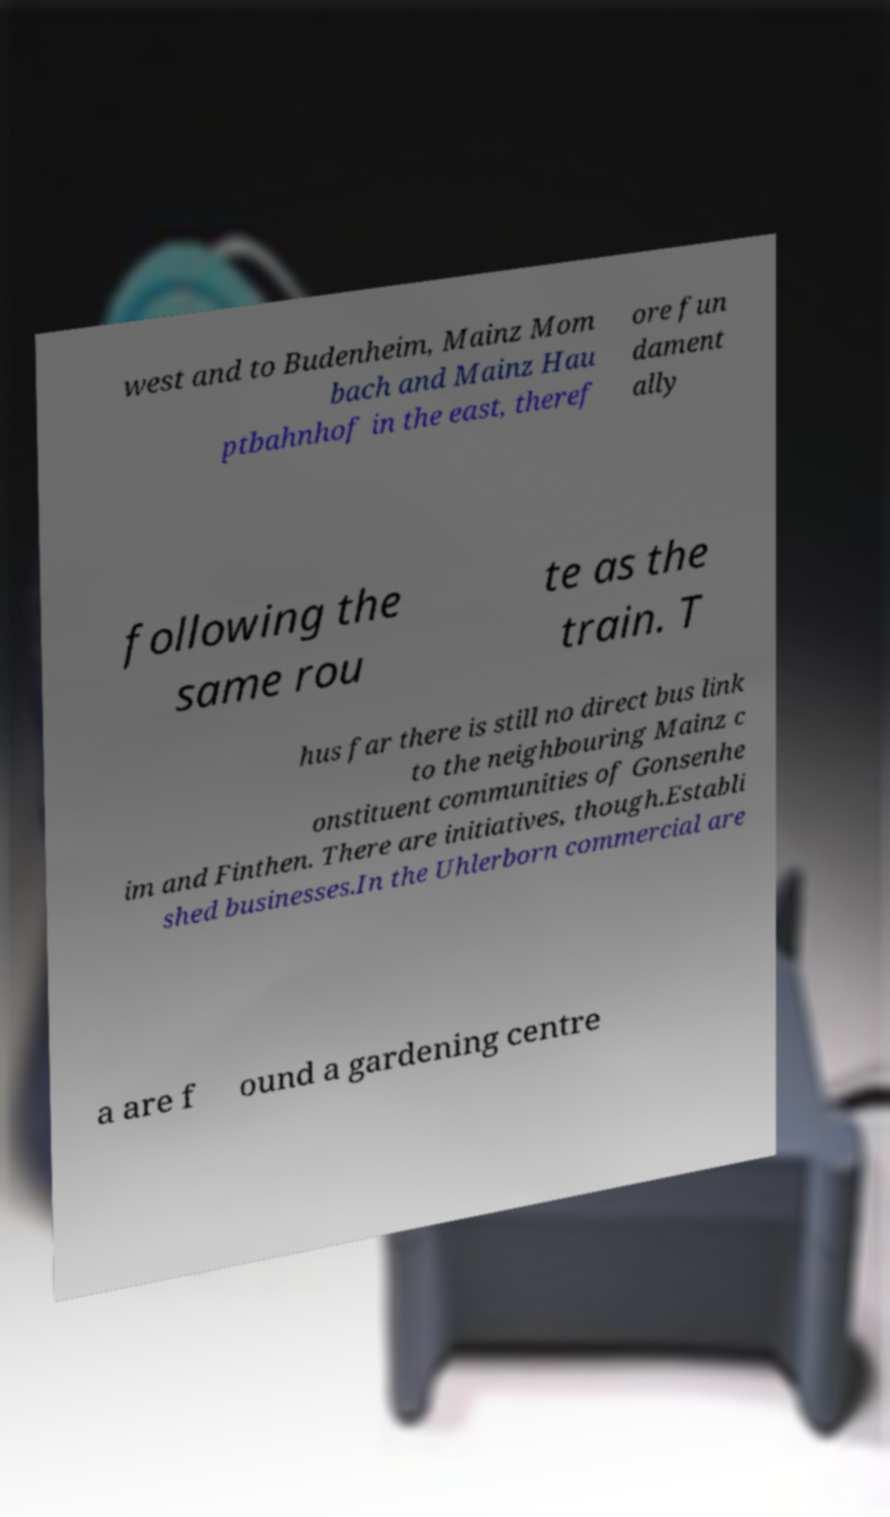Please read and relay the text visible in this image. What does it say? west and to Budenheim, Mainz Mom bach and Mainz Hau ptbahnhof in the east, theref ore fun dament ally following the same rou te as the train. T hus far there is still no direct bus link to the neighbouring Mainz c onstituent communities of Gonsenhe im and Finthen. There are initiatives, though.Establi shed businesses.In the Uhlerborn commercial are a are f ound a gardening centre 